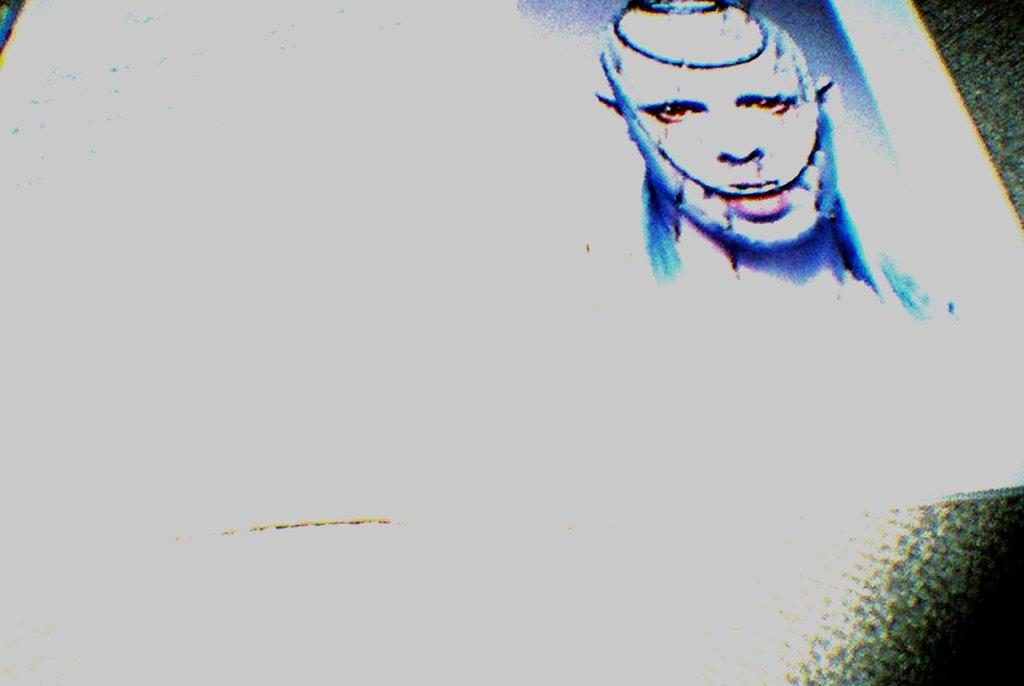What is present on the paper in the image? A face is printed on the paper. Can you describe the paper in the image? There is a paper in the image with a face printed on it. What type of ear is visible on the paper in the image? There is no ear present on the paper in the image; it only has a face printed on it. 